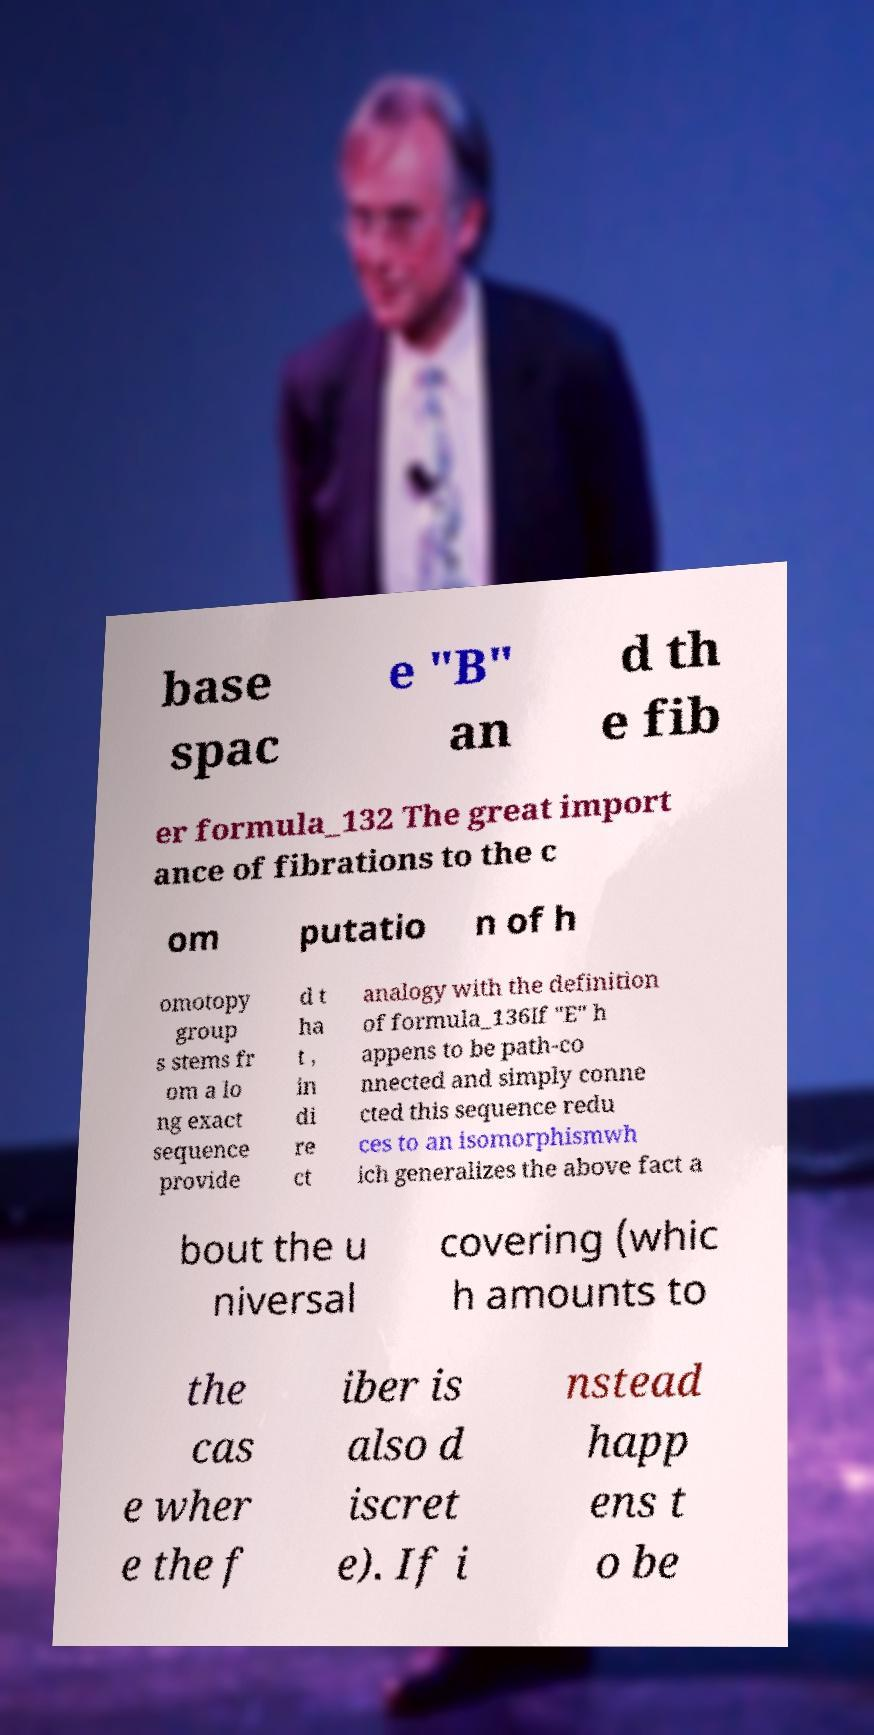There's text embedded in this image that I need extracted. Can you transcribe it verbatim? base spac e "B" an d th e fib er formula_132 The great import ance of fibrations to the c om putatio n of h omotopy group s stems fr om a lo ng exact sequence provide d t ha t , in di re ct analogy with the definition of formula_136If "E" h appens to be path-co nnected and simply conne cted this sequence redu ces to an isomorphismwh ich generalizes the above fact a bout the u niversal covering (whic h amounts to the cas e wher e the f iber is also d iscret e). If i nstead happ ens t o be 